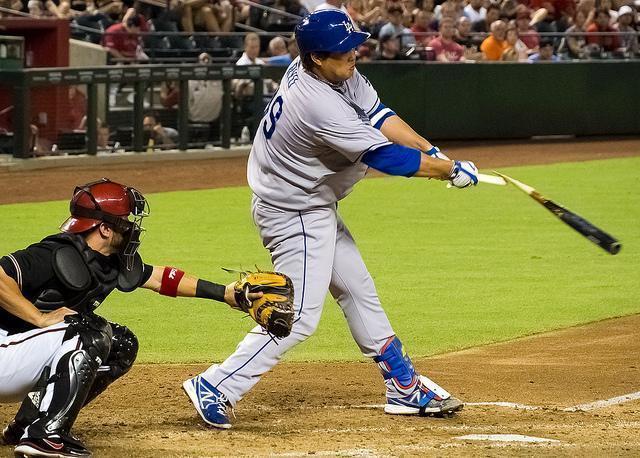What team is the batter playing for?
Choose the right answer from the provided options to respond to the question.
Options: Red sox, orioles, dodgers, yankees. Dodgers. 